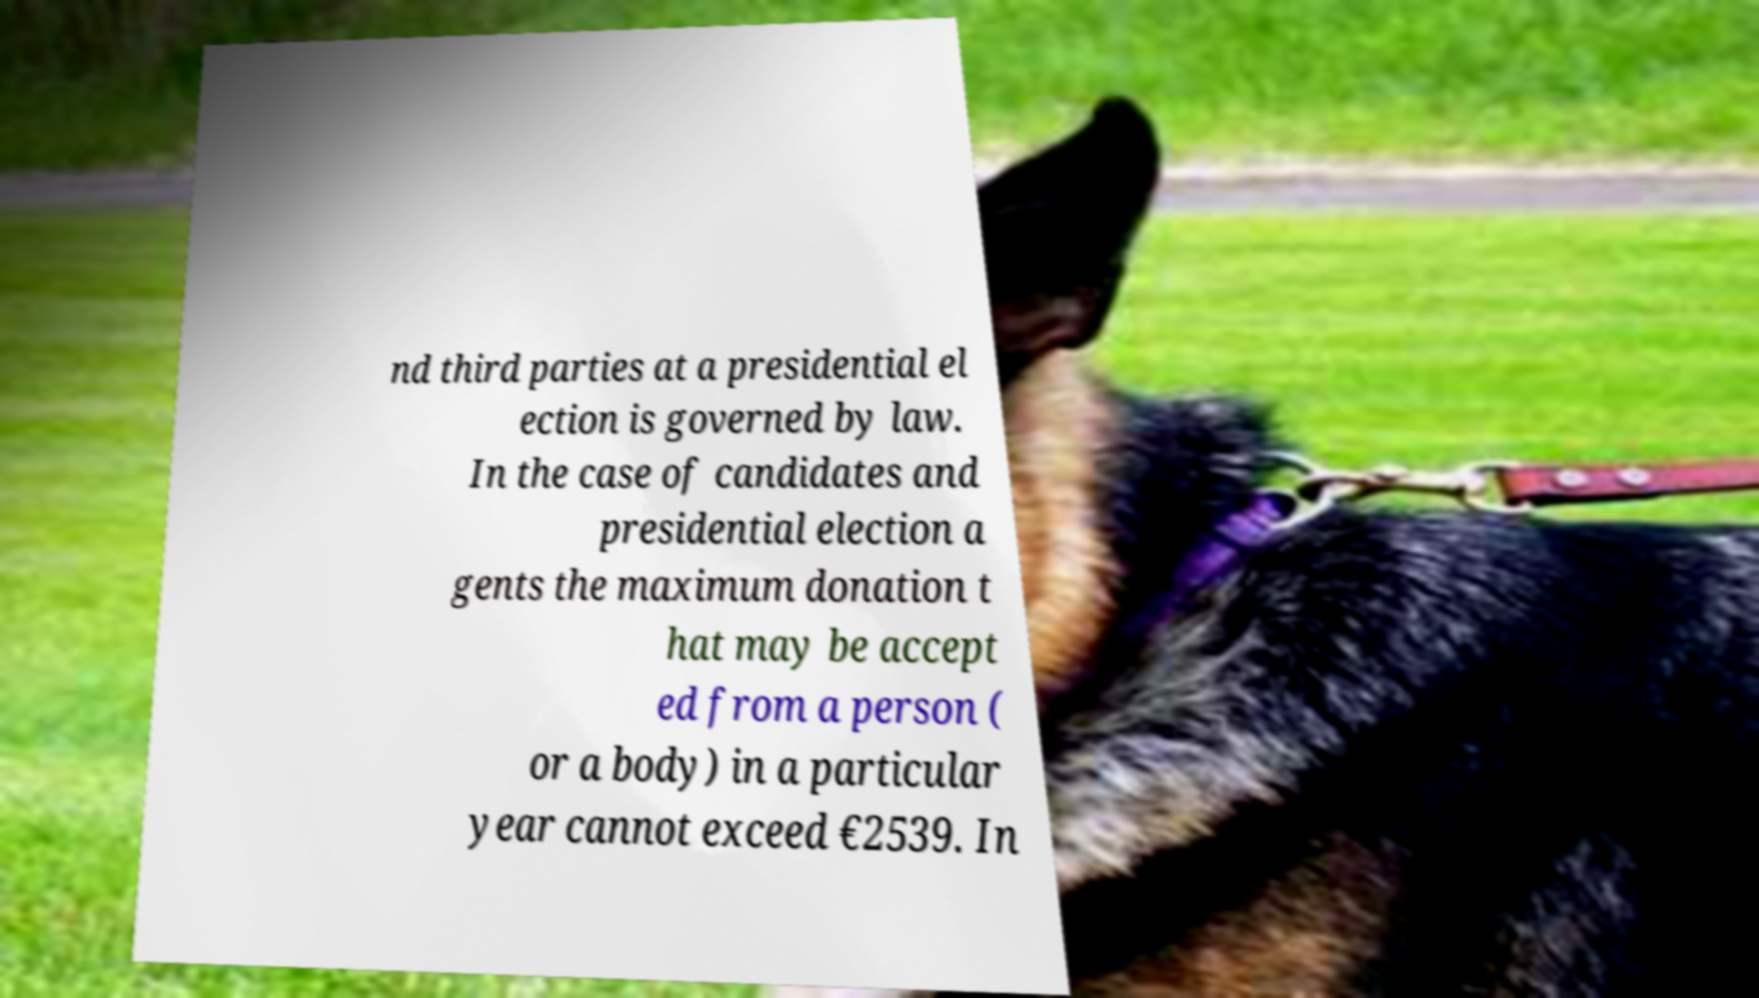What messages or text are displayed in this image? I need them in a readable, typed format. nd third parties at a presidential el ection is governed by law. In the case of candidates and presidential election a gents the maximum donation t hat may be accept ed from a person ( or a body) in a particular year cannot exceed €2539. In 